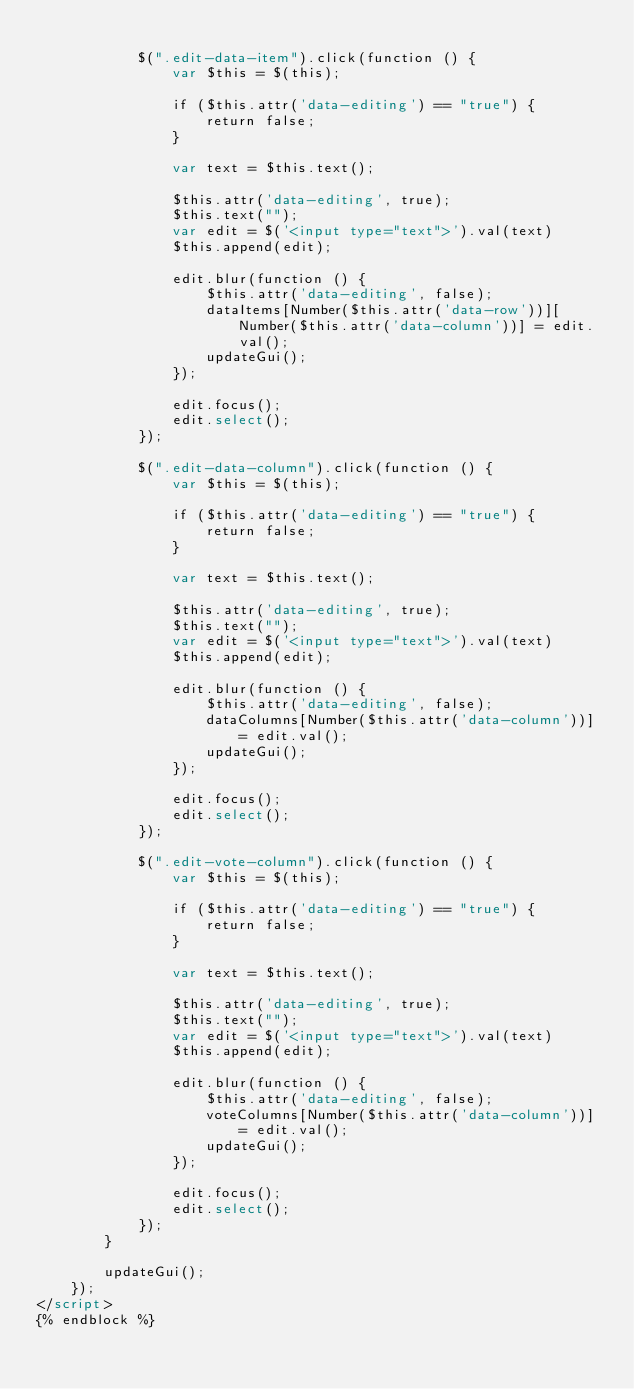Convert code to text. <code><loc_0><loc_0><loc_500><loc_500><_HTML_>
			$(".edit-data-item").click(function () {
				var $this = $(this);

				if ($this.attr('data-editing') == "true") {
					return false;
				}

				var text = $this.text();

				$this.attr('data-editing', true);
				$this.text("");
				var edit = $('<input type="text">').val(text)
				$this.append(edit);

				edit.blur(function () {
					$this.attr('data-editing', false);
					dataItems[Number($this.attr('data-row'))][Number($this.attr('data-column'))] = edit.val();
					updateGui();
				});

				edit.focus();
				edit.select();
			});

			$(".edit-data-column").click(function () {
				var $this = $(this);

				if ($this.attr('data-editing') == "true") {
					return false;
				}

				var text = $this.text();

				$this.attr('data-editing', true);
				$this.text("");
				var edit = $('<input type="text">').val(text)
				$this.append(edit);

				edit.blur(function () {
					$this.attr('data-editing', false);
					dataColumns[Number($this.attr('data-column'))] = edit.val();
					updateGui();
				});

				edit.focus();
				edit.select();
			});

			$(".edit-vote-column").click(function () {
				var $this = $(this);

				if ($this.attr('data-editing') == "true") {
					return false;
				}

				var text = $this.text();

				$this.attr('data-editing', true);
				$this.text("");
				var edit = $('<input type="text">').val(text)
				$this.append(edit);

				edit.blur(function () {
					$this.attr('data-editing', false);
					voteColumns[Number($this.attr('data-column'))] = edit.val();
					updateGui();
				});

				edit.focus();
				edit.select();
			});
		}

		updateGui();
	});
</script>
{% endblock %}
</code> 